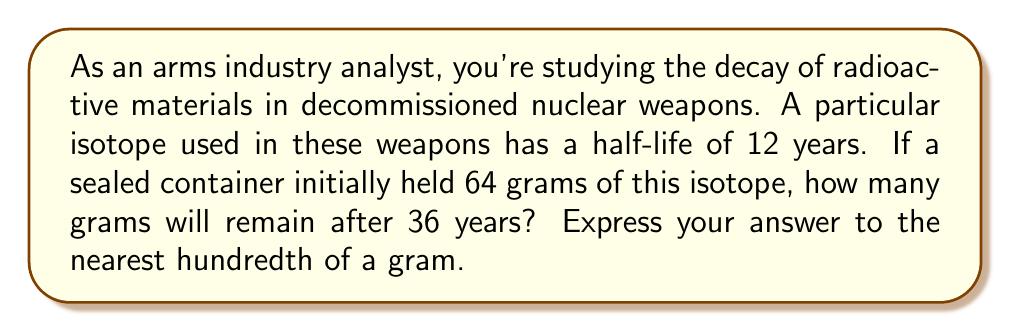Teach me how to tackle this problem. To solve this problem, we need to use the exponential decay formula:

$$ A(t) = A_0 \cdot (1/2)^{t/t_{1/2}} $$

Where:
$A(t)$ is the amount remaining after time $t$
$A_0$ is the initial amount
$t$ is the time elapsed
$t_{1/2}$ is the half-life

Given:
- Initial amount $A_0 = 64$ grams
- Half-life $t_{1/2} = 12$ years
- Time elapsed $t = 36$ years

Let's substitute these values into the formula:

$$ A(36) = 64 \cdot (1/2)^{36/12} $$

Simplify the exponent:
$$ A(36) = 64 \cdot (1/2)^3 $$

Calculate $(1/2)^3$:
$$ A(36) = 64 \cdot (1/8) $$

Multiply:
$$ A(36) = 8 $$

Therefore, after 36 years, 8 grams of the isotope will remain.
Answer: 8.00 grams 